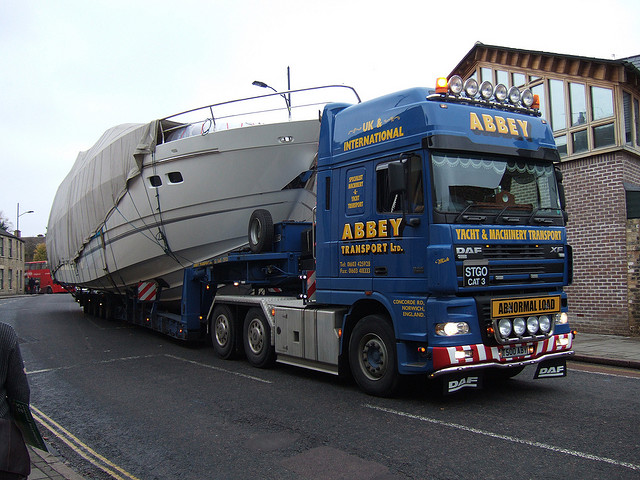Identify and read out the text in this image. ABBEY ABBEY TRANSPORT INTERNATIONLA UK DAF DAF LOAD ABNORMAL XF TRANSPORT MACHINERY &amp; YACHT 3 STGO DAF LTD. 